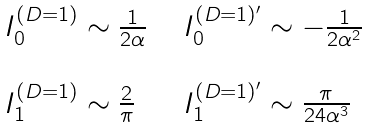<formula> <loc_0><loc_0><loc_500><loc_500>\begin{array} { l l } I _ { 0 } ^ { ( D = 1 ) } \sim \frac { 1 } { 2 \alpha } \ \ & I _ { 0 } ^ { ( D = 1 ) ^ { \prime } } \sim - \frac { 1 } { 2 \alpha ^ { 2 } } \\ & \\ I _ { 1 } ^ { ( D = 1 ) } \sim \frac { 2 } { \pi } \ \ & I _ { 1 } ^ { ( D = 1 ) ^ { \prime } } \sim \frac { \pi } { 2 4 \alpha ^ { 3 } } \end{array}</formula> 